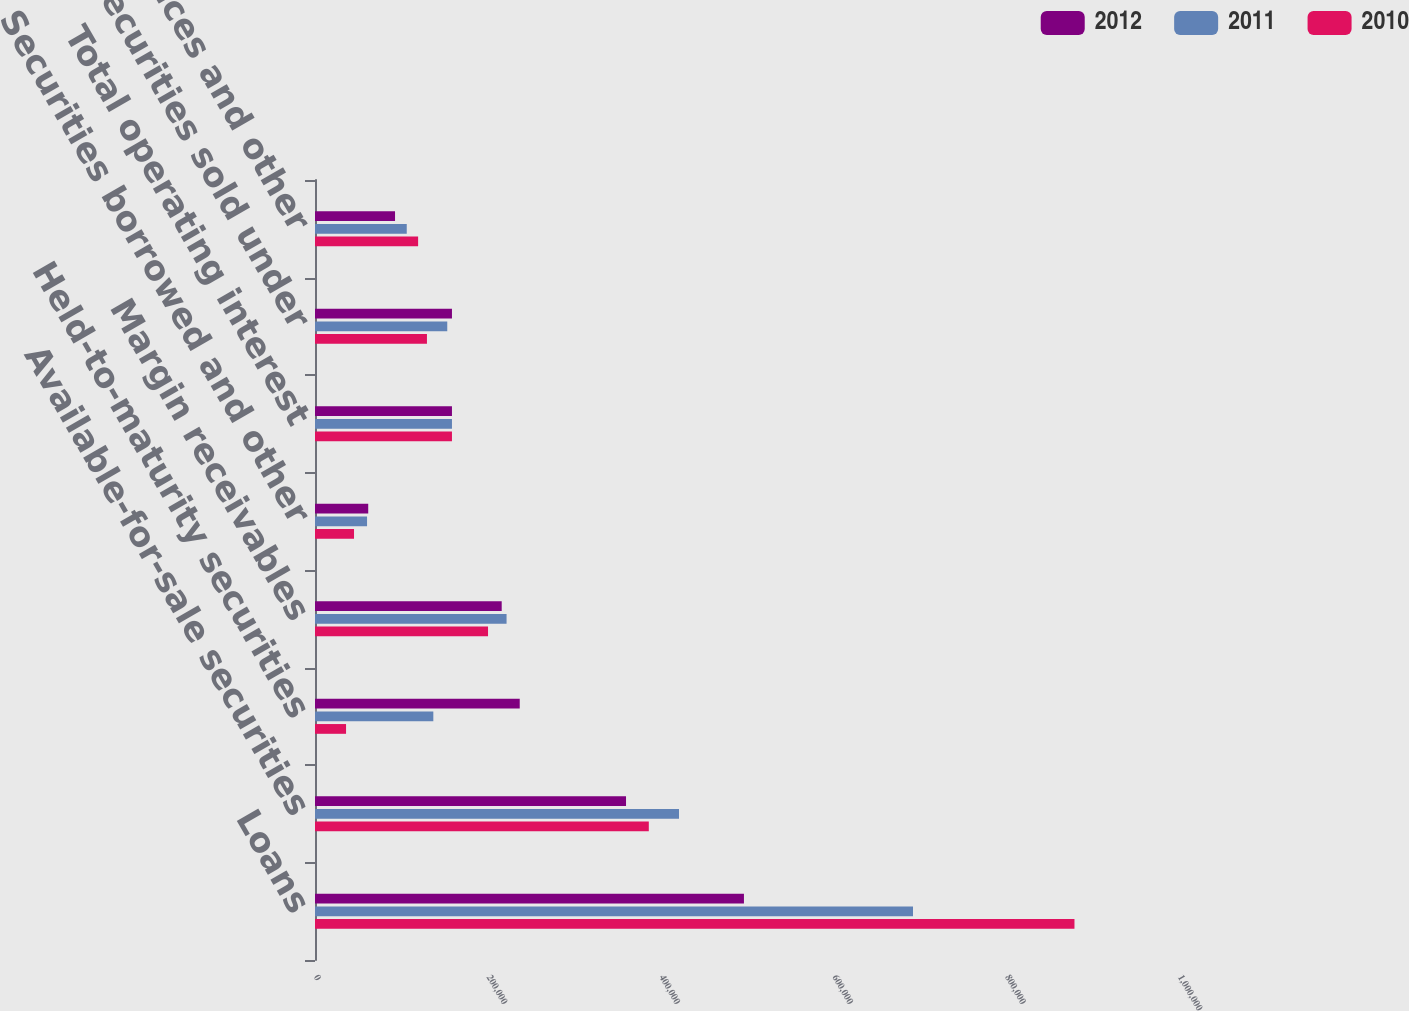Convert chart to OTSL. <chart><loc_0><loc_0><loc_500><loc_500><stacked_bar_chart><ecel><fcel>Loans<fcel>Available-for-sale securities<fcel>Held-to-maturity securities<fcel>Margin receivables<fcel>Securities borrowed and other<fcel>Total operating interest<fcel>Securities sold under<fcel>FHLB advances and other<nl><fcel>2012<fcel>496466<fcel>359977<fcel>236961<fcel>216086<fcel>61608<fcel>158518<fcel>158518<fcel>92630<nl><fcel>2011<fcel>692127<fcel>421304<fcel>136953<fcel>221717<fcel>60238<fcel>158518<fcel>153079<fcel>106201<nl><fcel>2010<fcel>879013<fcel>386347<fcel>35930<fcel>200260<fcel>45163<fcel>158518<fcel>129574<fcel>119344<nl></chart> 